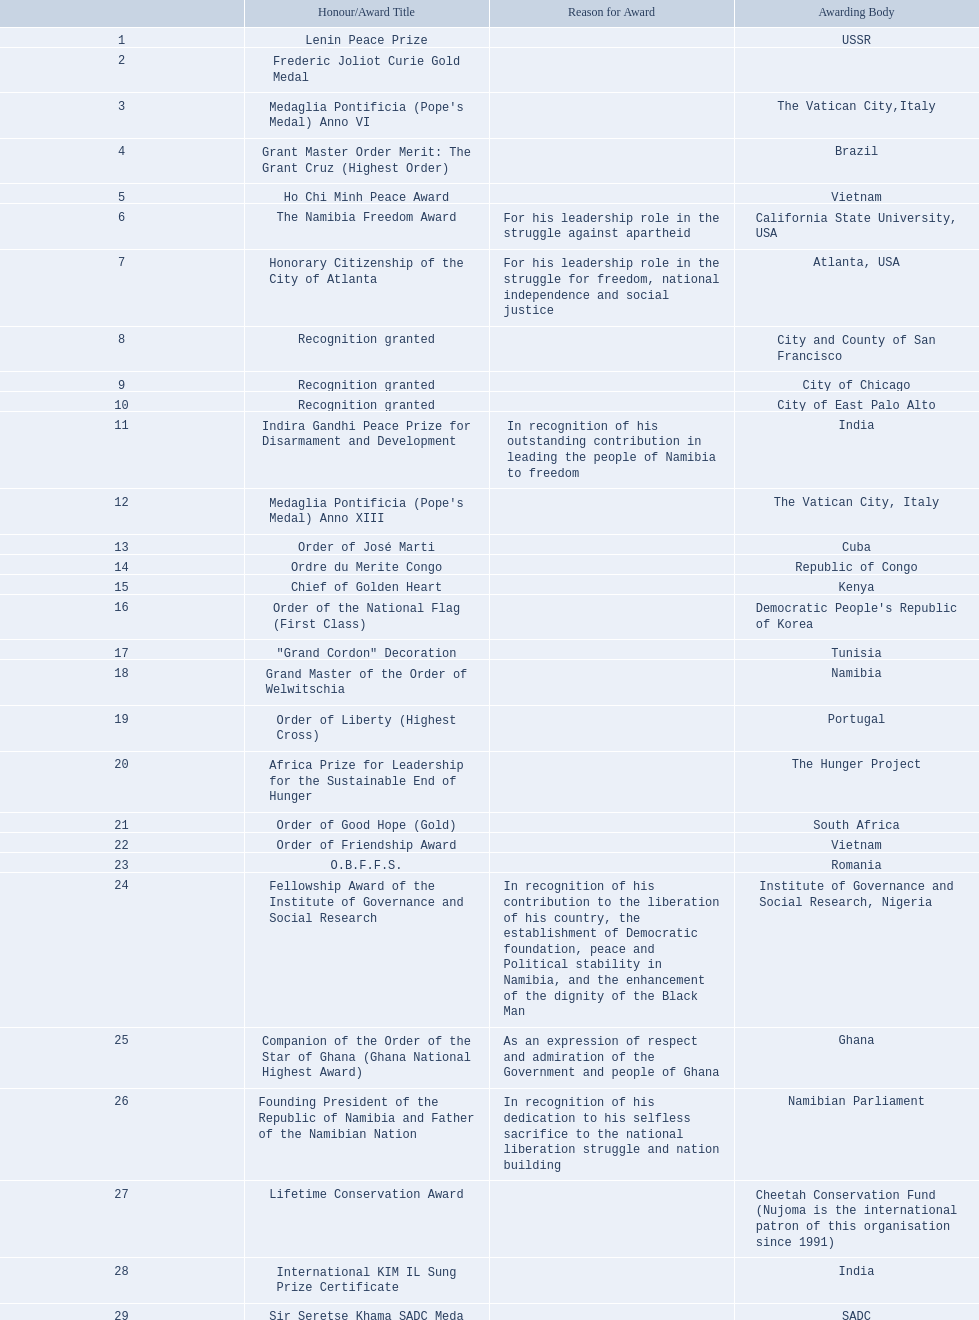What awards did sam nujoma win? 1, 1973, Lenin Peace Prize, Frederic Joliot Curie Gold Medal, Medaglia Pontificia (Pope's Medal) Anno VI, Grant Master Order Merit: The Grant Cruz (Highest Order), Ho Chi Minh Peace Award, The Namibia Freedom Award, Honorary Citizenship of the City of Atlanta, Recognition granted, Recognition granted, Recognition granted, Indira Gandhi Peace Prize for Disarmament and Development, Medaglia Pontificia (Pope's Medal) Anno XIII, Order of José Marti, Ordre du Merite Congo, Chief of Golden Heart, Order of the National Flag (First Class), "Grand Cordon" Decoration, Grand Master of the Order of Welwitschia, Order of Liberty (Highest Cross), Africa Prize for Leadership for the Sustainable End of Hunger, Order of Good Hope (Gold), Order of Friendship Award, O.B.F.F.S., Fellowship Award of the Institute of Governance and Social Research, Companion of the Order of the Star of Ghana (Ghana National Highest Award), Founding President of the Republic of Namibia and Father of the Namibian Nation, Lifetime Conservation Award, International KIM IL Sung Prize Certificate, Sir Seretse Khama SADC Meda. Who was the awarding body for the o.b.f.f.s award? Romania. 